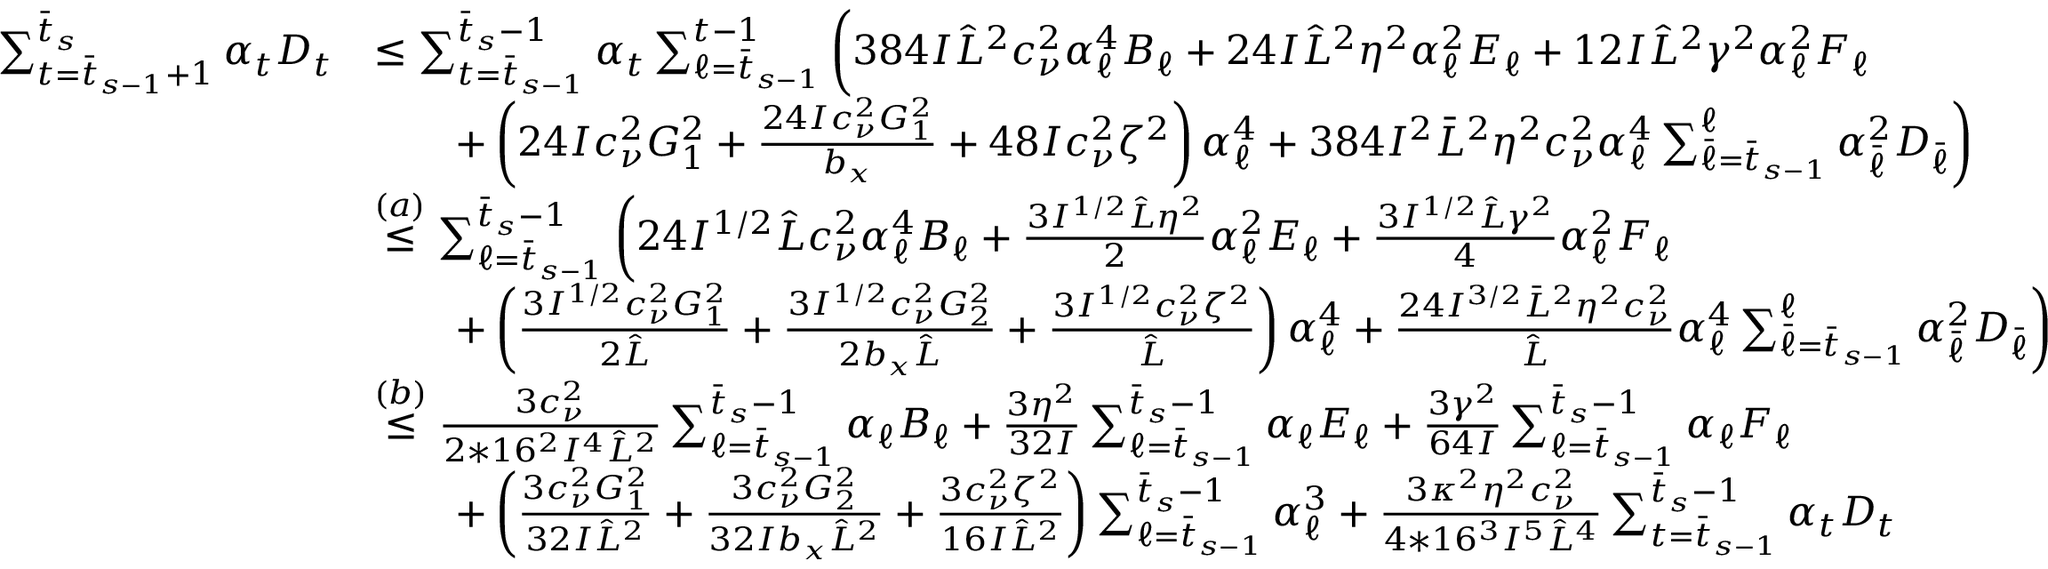Convert formula to latex. <formula><loc_0><loc_0><loc_500><loc_500>\begin{array} { r l } { \sum _ { t = \bar { t } _ { s - 1 } + 1 } ^ { \bar { t } _ { s } } \alpha _ { t } D _ { t } } & { \leq \sum _ { t = \bar { t } _ { s - 1 } } ^ { \bar { t } _ { s } - 1 } \alpha _ { t } \sum _ { \ell = \bar { t } _ { s - 1 } } ^ { t - 1 } \left ( 3 8 4 I \hat { L } ^ { 2 } c _ { \nu } ^ { 2 } \alpha _ { \ell } ^ { 4 } B _ { \ell } + 2 4 I \hat { L } ^ { 2 } \eta ^ { 2 } \alpha _ { \ell } ^ { 2 } E _ { \ell } + 1 2 I \hat { L } ^ { 2 } \gamma ^ { 2 } \alpha _ { \ell } ^ { 2 } F _ { \ell } } \\ & { \quad + \left ( 2 4 I c _ { \nu } ^ { 2 } G _ { 1 } ^ { 2 } + \frac { 2 4 I c _ { \nu } ^ { 2 } G _ { 1 } ^ { 2 } } { b _ { x } } + 4 8 I c _ { \nu } ^ { 2 } \zeta ^ { 2 } \right ) \alpha _ { \ell } ^ { 4 } + 3 8 4 I ^ { 2 } \bar { L } ^ { 2 } \eta ^ { 2 } c _ { \nu } ^ { 2 } \alpha _ { \ell } ^ { 4 } \sum _ { \bar { \ell } = \bar { t } _ { s - 1 } } ^ { \ell } \alpha _ { \bar { \ell } } ^ { 2 } D _ { \bar { \ell } } \right ) } \\ & { \overset { ( a ) } { \leq } \sum _ { \ell = \bar { t } _ { s - 1 } } ^ { \bar { t } _ { s } - 1 } \left ( 2 4 I ^ { 1 / 2 } \hat { L } c _ { \nu } ^ { 2 } \alpha _ { \ell } ^ { 4 } B _ { \ell } + \frac { 3 I ^ { 1 / 2 } \hat { L } \eta ^ { 2 } } { 2 } \alpha _ { \ell } ^ { 2 } E _ { \ell } + \frac { 3 I ^ { 1 / 2 } \hat { L } \gamma ^ { 2 } } { 4 } \alpha _ { \ell } ^ { 2 } F _ { \ell } } \\ & { \quad + \left ( \frac { 3 I ^ { 1 / 2 } c _ { \nu } ^ { 2 } G _ { 1 } ^ { 2 } } { 2 \hat { L } } + \frac { 3 I ^ { 1 / 2 } c _ { \nu } ^ { 2 } G _ { 2 } ^ { 2 } } { 2 b _ { x } \hat { L } } + \frac { 3 I ^ { 1 / 2 } c _ { \nu } ^ { 2 } \zeta ^ { 2 } } { \hat { L } } \right ) \alpha _ { \ell } ^ { 4 } + \frac { 2 4 I ^ { 3 / 2 } \bar { L } ^ { 2 } \eta ^ { 2 } c _ { \nu } ^ { 2 } } { \hat { L } } \alpha _ { \ell } ^ { 4 } \sum _ { \bar { \ell } = \bar { t } _ { s - 1 } } ^ { \ell } \alpha _ { \bar { \ell } } ^ { 2 } D _ { \bar { \ell } } \right ) } \\ & { \overset { ( b ) } { \leq } \frac { 3 c _ { \nu } ^ { 2 } } { 2 * 1 6 ^ { 2 } I ^ { 4 } \hat { L } ^ { 2 } } \sum _ { \ell = \bar { t } _ { s - 1 } } ^ { \bar { t } _ { s } - 1 } \alpha _ { \ell } B _ { \ell } + \frac { 3 \eta ^ { 2 } } { 3 2 I } \sum _ { \ell = \bar { t } _ { s - 1 } } ^ { \bar { t } _ { s } - 1 } \alpha _ { \ell } E _ { \ell } + \frac { 3 \gamma ^ { 2 } } { 6 4 I } \sum _ { \ell = \bar { t } _ { s - 1 } } ^ { \bar { t } _ { s } - 1 } \alpha _ { \ell } F _ { \ell } } \\ & { \quad + \left ( \frac { 3 c _ { \nu } ^ { 2 } G _ { 1 } ^ { 2 } } { 3 2 I \hat { L } ^ { 2 } } + \frac { 3 c _ { \nu } ^ { 2 } G _ { 2 } ^ { 2 } } { 3 2 I b _ { x } \hat { L } ^ { 2 } } + \frac { 3 c _ { \nu } ^ { 2 } \zeta ^ { 2 } } { 1 6 I \hat { L } ^ { 2 } } \right ) \sum _ { \ell = \bar { t } _ { s - 1 } } ^ { \bar { t } _ { s } - 1 } \alpha _ { \ell } ^ { 3 } + \frac { 3 \kappa ^ { 2 } \eta ^ { 2 } c _ { \nu } ^ { 2 } } { 4 * 1 6 ^ { 3 } I ^ { 5 } \hat { L } ^ { 4 } } \sum _ { t = \bar { t } _ { s - 1 } } ^ { \bar { t } _ { s } - 1 } \alpha _ { t } D _ { t } } \end{array}</formula> 